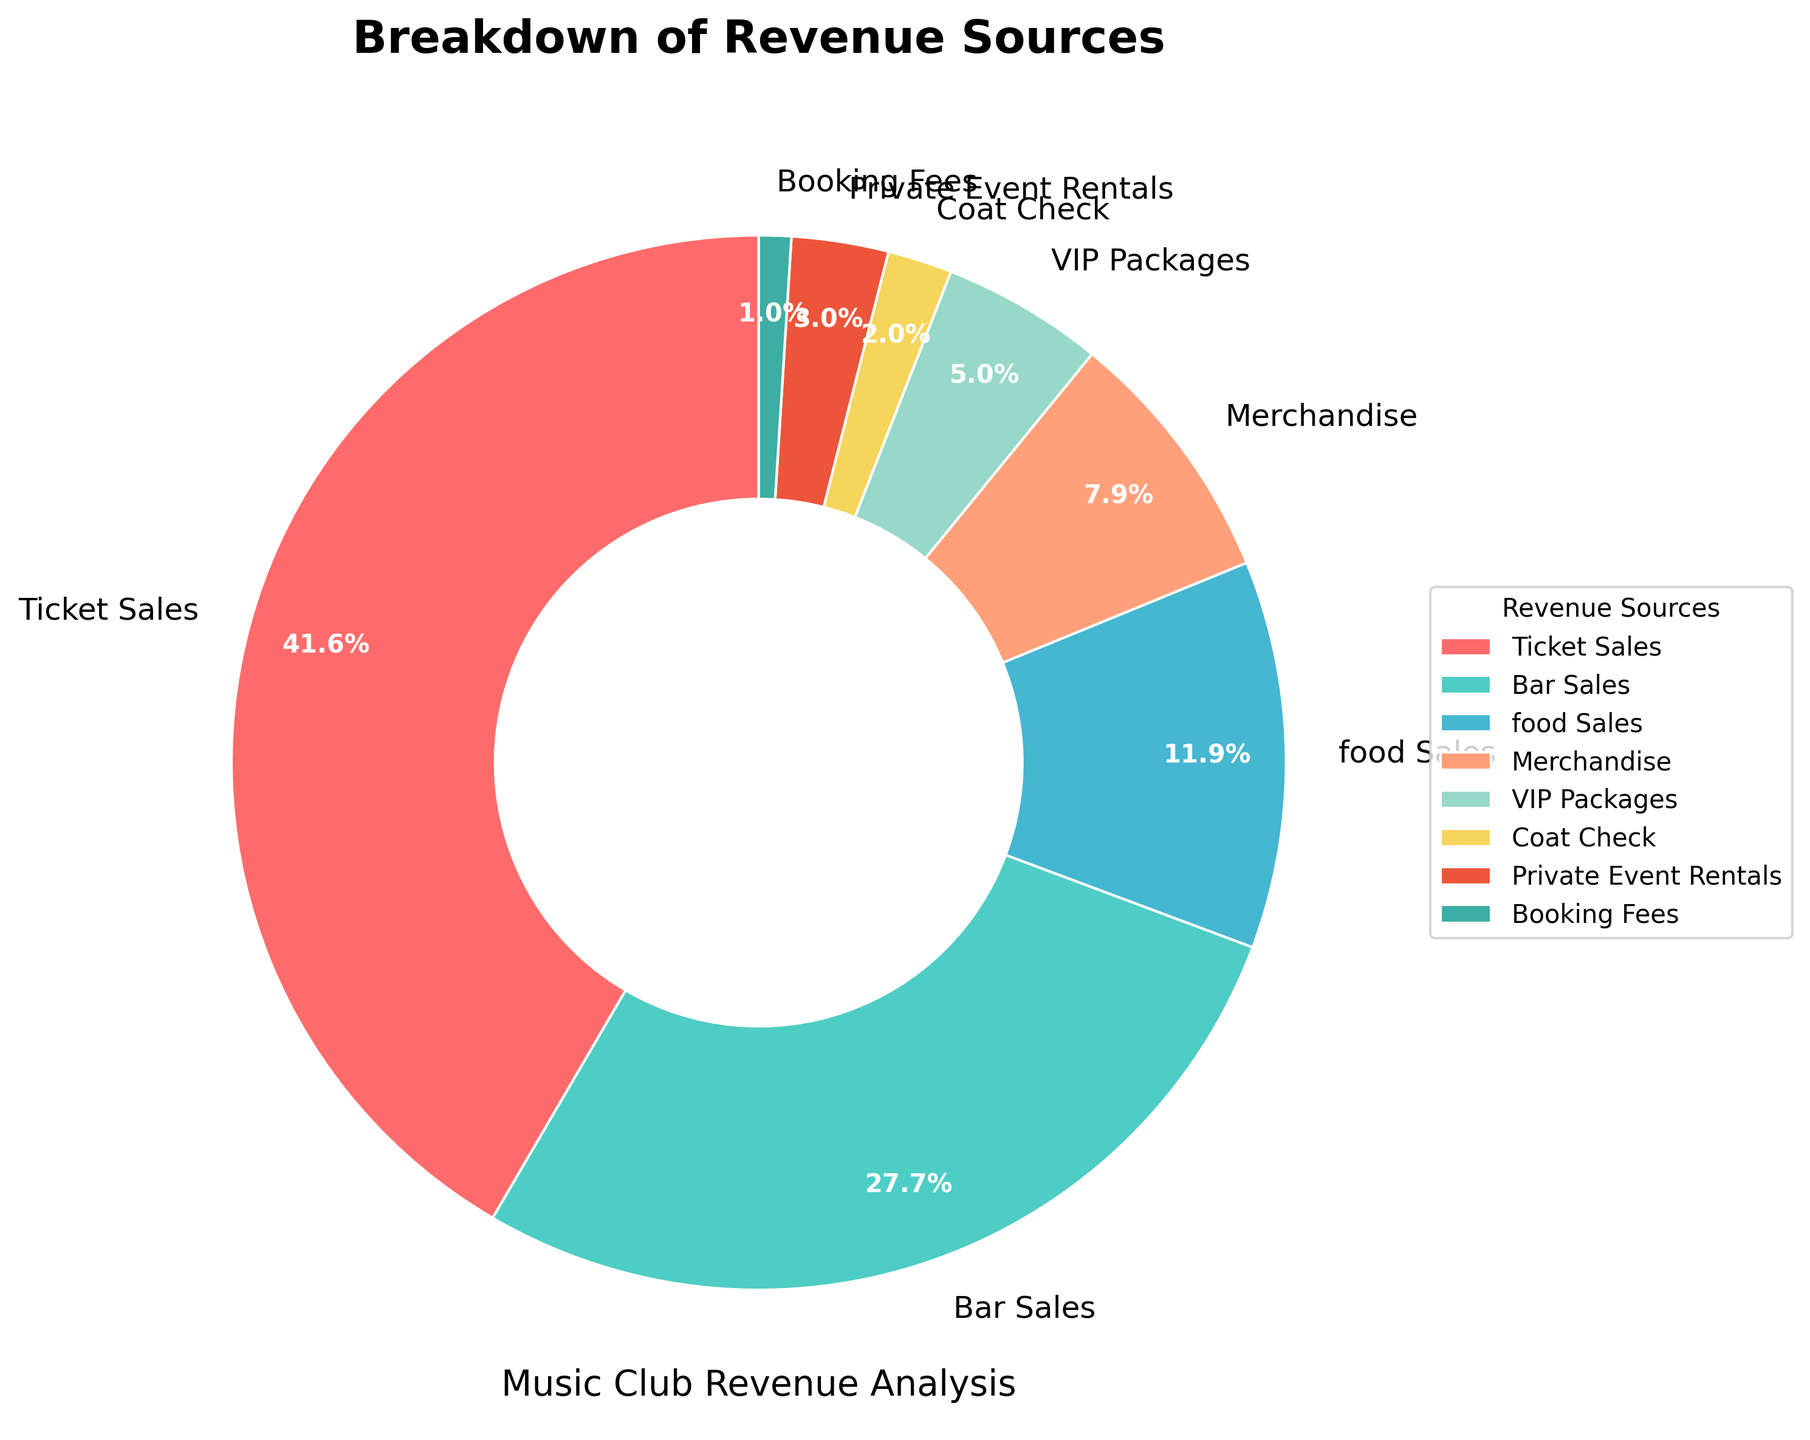Which revenue source contributes the most to the revenue? The largest slice in the pie chart is labeled "Ticket Sales," which accounts for 42% of the total revenue, making it the highest contributor.
Answer: Ticket Sales What's the combined percentage of Bar Sales and Food Sales? Bar Sales account for 28% and Food Sales account for 12%. Adding them together, 28% + 12% = 40%.
Answer: 40% How does the percentage of Merchandise compare to VIP Packages? Merchandise accounts for 8% of the revenue, whereas VIP Packages account for 5%. The Merchandise percentage is larger.
Answer: Larger What is the sum of the percentages for the three smallest revenue sources? The three smallest sources are Booking Fees (1%), Coat Check (2%), and Private Event Rentals (3%). Summing them, 1% + 2% + 3% = 6%.
Answer: 6% Which sources, when combined, make up 50% of the revenue? Ticket Sales (42%) and Bar Sales (28%) are the largest contributors. When combined: 42% + 28% = 70%. Since that exceeds 50%, let's check Food Sales (12%) and Merchandise (8%). Thus, Ticket Sales (42%) + Food Sales (12%) = 54%, and exceeds 50% too. So, Bar Sales (28%) + Food Sales (12%) + Merchandise (8%) = 48%, still under. So, Ticket Sales + Bar Sales = 42% + 28% = 70%, so no combinations below except including Ticket Sales works.
Answer: Ticket Sales Which wedge is represented in green? In the pie chart, the wedge for "Bar Sales" is depicted in green.
Answer: Bar Sales How much greater is the percentage of Ticket Sales compared to Private Event Rentals? Ticket Sales contribute 42% while Private Event Rentals contribute 3%. The difference is 42% - 3% = 39%.
Answer: 39% What revenue sources together make up the second highest percentage after Ticket Sales? Ticket Sales is the highest with 42%. The next highest individual is Bar Sales with 28%, and no combination of lower slices adds to more.
Answer: Bar Sales Is the total percentage of VIP Packages and Coat Check more or less than Food Sales? VIP Packages contribute 5% and Coat Check contributes 2%. Their total is 5% + 2% = 7%, which is less than Food Sales at 12%.
Answer: Less 